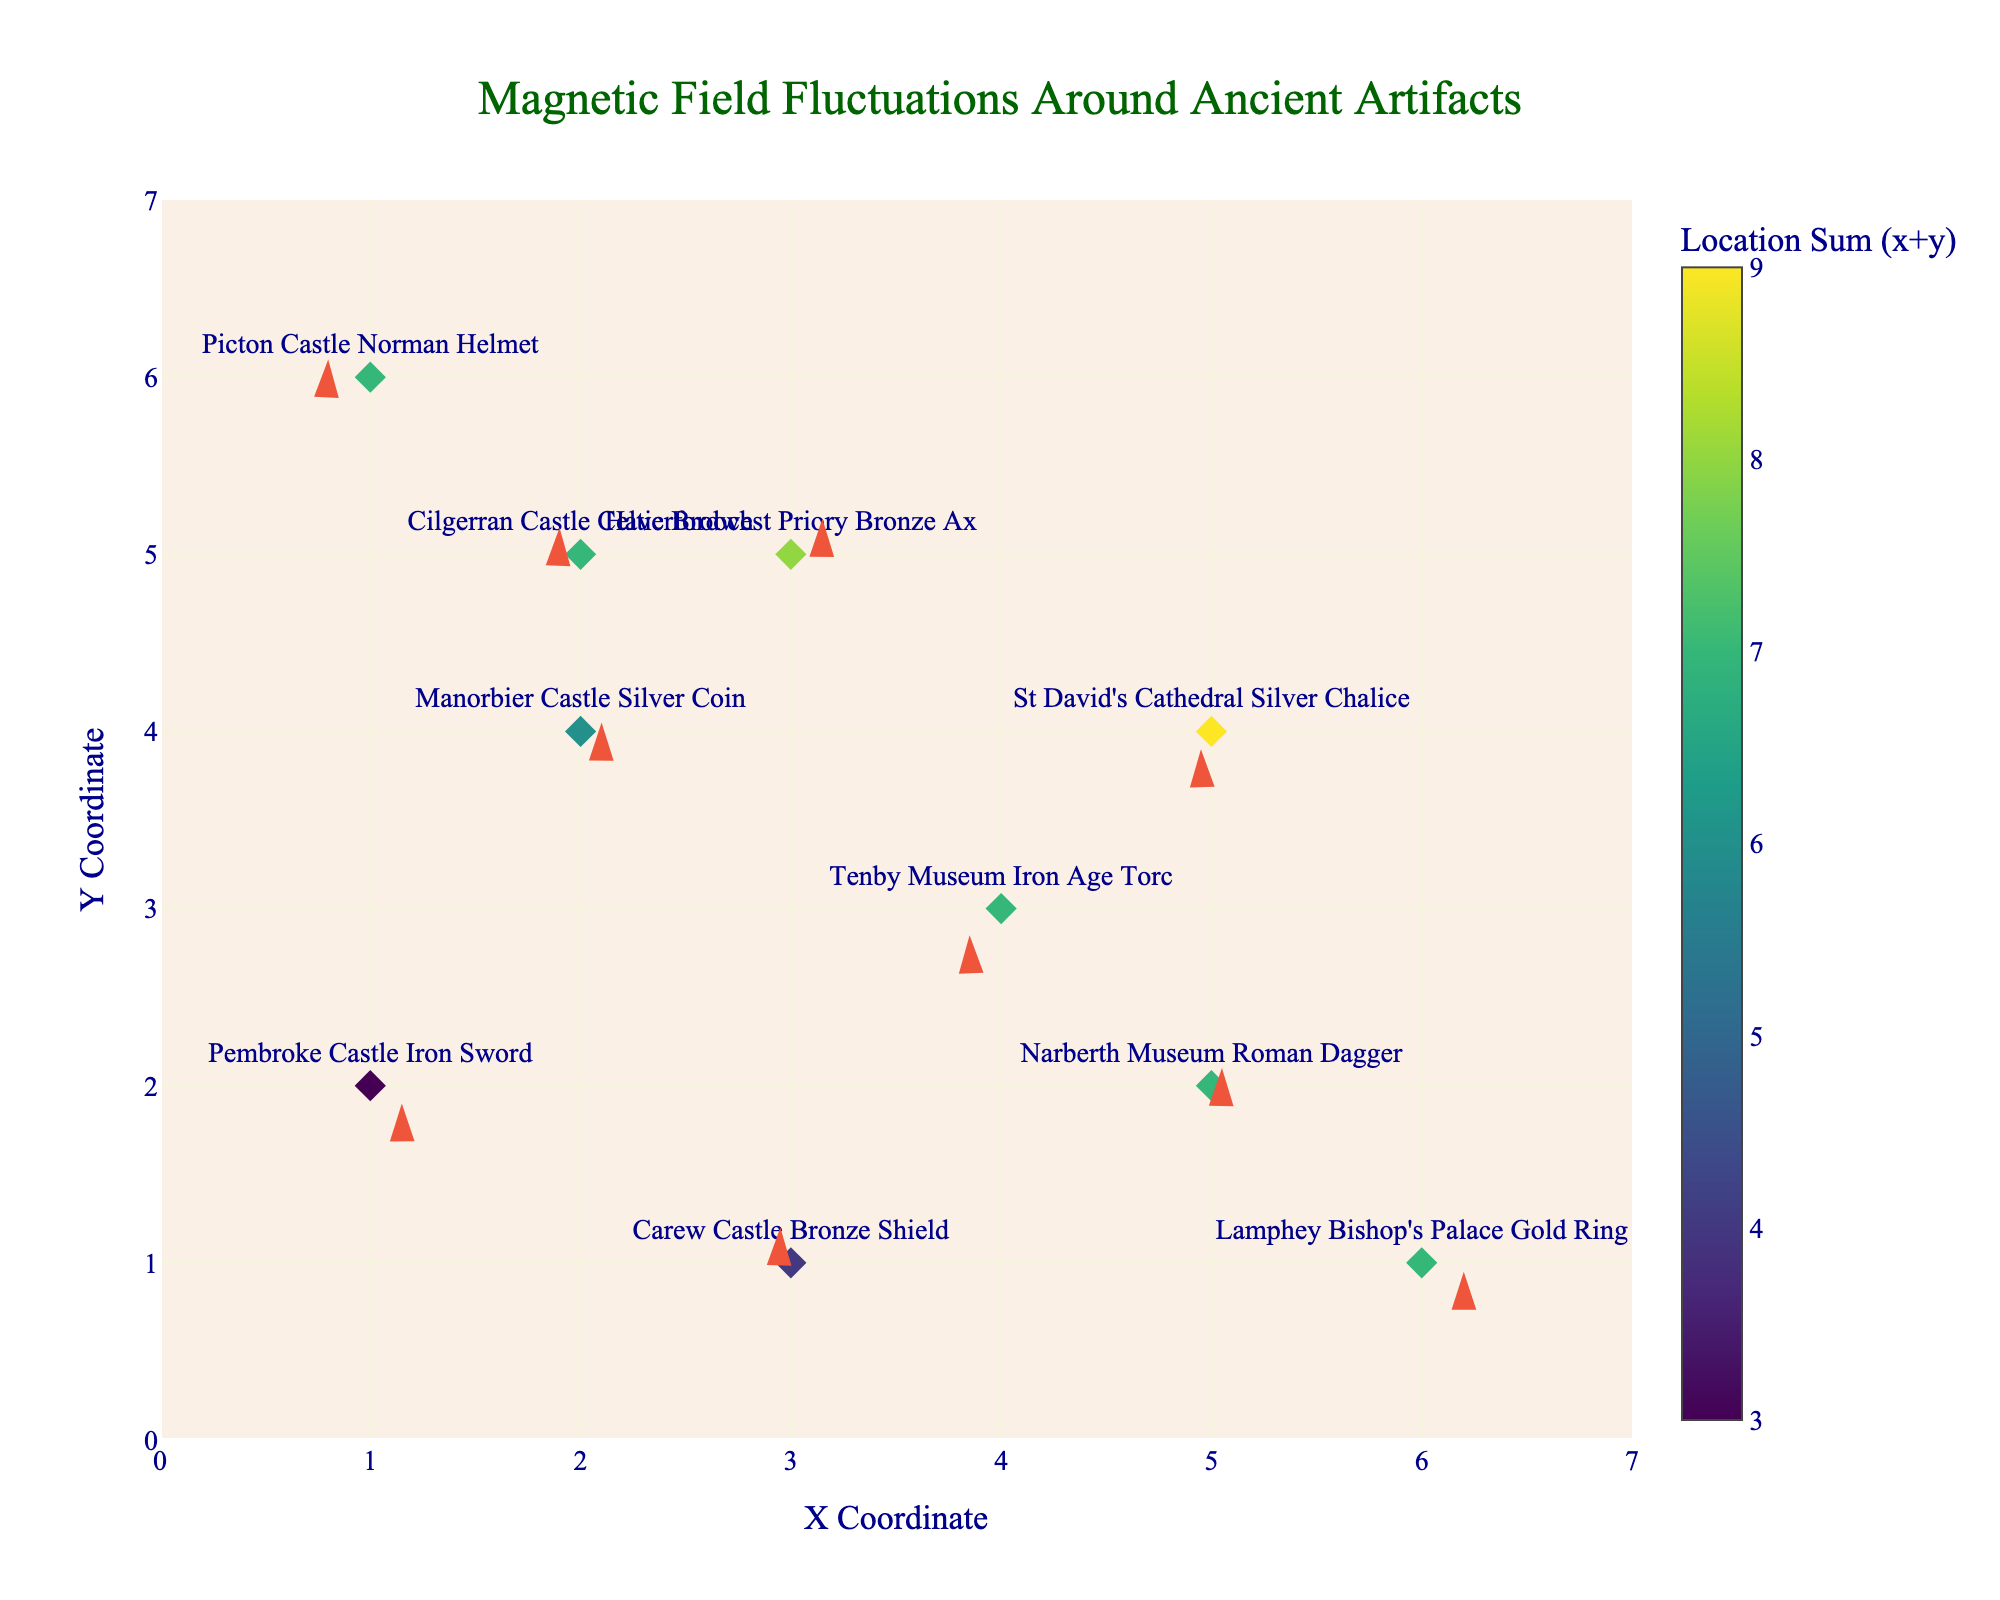What is the title of the figure? The title is clearly indicated at the top center of the figure in a large, old-fashioned font. It reads "Magnetic Field Fluctuations Around Ancient Artifacts".
Answer: Magnetic Field Fluctuations Around Ancient Artifacts What are the x and y-axis titles in the plot? The x-axis and y-axis titles are located beneath and to the left of the corresponding axes. They are labeled "X Coordinate" for the x-axis and "Y Coordinate" for the y-axis.
Answer: X Coordinate; Y Coordinate Which artifact has the largest magnitude of magnetic fluctuation? By examining the length of the arrows, we can identify the longest arrow which correlates to the artifact with the largest fluctuation. The arrow for "Haverfordwest Priory Bronze Ax" is the longest.
Answer: Haverfordwest Priory Bronze Ax Which artifacts are located at positions where both x and y coordinates are equal? To answer this, we look at the data points where the x and y coordinates match. Here, none of the artifacts are positioned where x equals y.
Answer: None How many artifacts have a positive u component of the magnetic fluctuation? By counting the arrows pointing towards the right (indicating positive u components), we identify four artifacts with positive u values: "Pembroke Castle Iron Sword", "Manorbier Castle Silver Coin", "Narberth Museum Roman Dagger", and "Haverfordwest Priory Bronze Ax".
Answer: 4 Which artifact is at the highest y coordinate? Looking at the figure, the artifact at the highest y coordinate is "Picton Castle Norman Helmet", which is located at y=6.
Answer: Picton Castle Norman Helmet What is the location sum (x + y) for the artifact "Lamphey Bishop's Palace Gold Ring"? The artifact “Lamphey Bishop's Palace Gold Ring” is located at (6, 1). The location sum is calculated as 6 + 1 = 7.
Answer: 7 Which artifact shows a negative x-directional fluctuation with zero change in the y-direction? We need to find an artifact represented by an arrow pointing directly to the left, indicating a negative u component and zero v component. "Tenby Museum Iron Age Torc" has u = -0.3 and v = -0.3, not fitting the criteria. Therefore, none satisfy.
Answer: None Compare the direction of magnetic fluctuation between "Carew Castle Bronze Shield" and "Tenby Museum Iron Age Torc". Which one points more upwards? By looking at the orientation of the arrows, the "Carew Castle Bronze Shield" (u = -0.1, v = 0.4) points more upwards compared to "Tenby Museum Iron Age Torc" (u = -0.3, v = -0.3).
Answer: Carew Castle Bronze Shield What's the average x coordinate of all artifacts? The average x coordinate is calculated by summing the x coordinates (1+3+2+4+5+2+6+1+3+5) = 32 and dividing by the number of artifacts (10), giving 32/10 = 3.2.
Answer: 3.2 